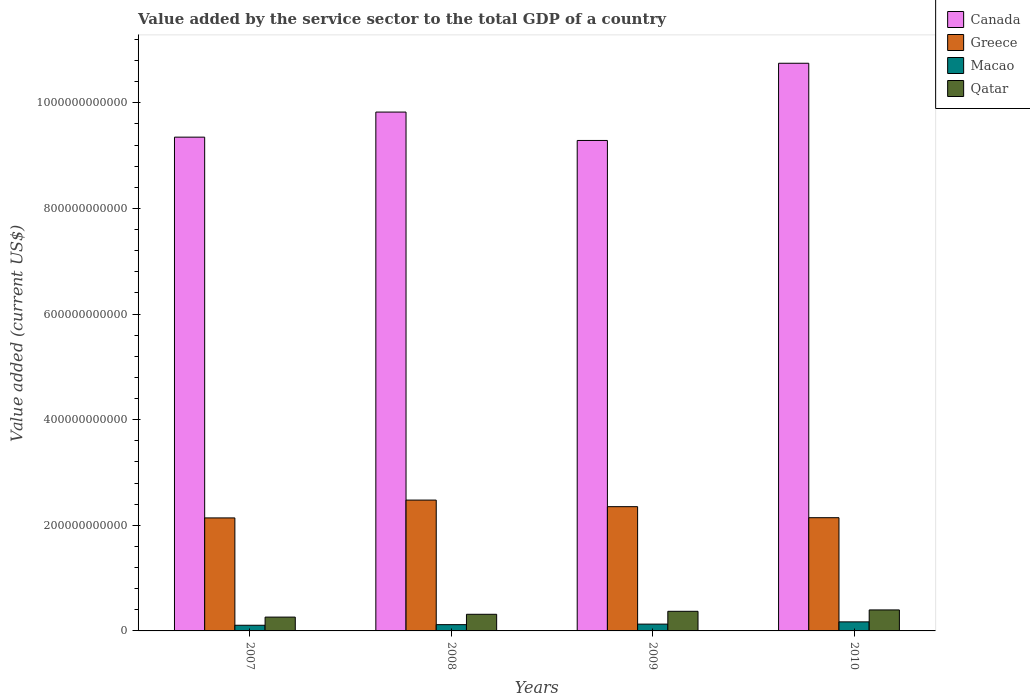How many groups of bars are there?
Ensure brevity in your answer.  4. Are the number of bars on each tick of the X-axis equal?
Offer a terse response. Yes. How many bars are there on the 3rd tick from the left?
Offer a very short reply. 4. What is the value added by the service sector to the total GDP in Canada in 2007?
Offer a very short reply. 9.35e+11. Across all years, what is the maximum value added by the service sector to the total GDP in Qatar?
Make the answer very short. 3.98e+1. Across all years, what is the minimum value added by the service sector to the total GDP in Qatar?
Give a very brief answer. 2.62e+1. In which year was the value added by the service sector to the total GDP in Macao minimum?
Make the answer very short. 2007. What is the total value added by the service sector to the total GDP in Macao in the graph?
Your response must be concise. 5.26e+1. What is the difference between the value added by the service sector to the total GDP in Macao in 2009 and that in 2010?
Give a very brief answer. -4.26e+09. What is the difference between the value added by the service sector to the total GDP in Qatar in 2010 and the value added by the service sector to the total GDP in Greece in 2009?
Offer a very short reply. -1.96e+11. What is the average value added by the service sector to the total GDP in Macao per year?
Provide a succinct answer. 1.32e+1. In the year 2007, what is the difference between the value added by the service sector to the total GDP in Qatar and value added by the service sector to the total GDP in Greece?
Your answer should be compact. -1.88e+11. What is the ratio of the value added by the service sector to the total GDP in Greece in 2008 to that in 2009?
Offer a very short reply. 1.05. Is the value added by the service sector to the total GDP in Qatar in 2007 less than that in 2009?
Your response must be concise. Yes. What is the difference between the highest and the second highest value added by the service sector to the total GDP in Macao?
Your response must be concise. 4.26e+09. What is the difference between the highest and the lowest value added by the service sector to the total GDP in Canada?
Your answer should be compact. 1.46e+11. In how many years, is the value added by the service sector to the total GDP in Qatar greater than the average value added by the service sector to the total GDP in Qatar taken over all years?
Provide a short and direct response. 2. Is the sum of the value added by the service sector to the total GDP in Qatar in 2007 and 2009 greater than the maximum value added by the service sector to the total GDP in Macao across all years?
Make the answer very short. Yes. What does the 4th bar from the left in 2009 represents?
Your response must be concise. Qatar. What does the 3rd bar from the right in 2007 represents?
Your response must be concise. Greece. How many bars are there?
Keep it short and to the point. 16. How many years are there in the graph?
Ensure brevity in your answer.  4. What is the difference between two consecutive major ticks on the Y-axis?
Offer a very short reply. 2.00e+11. Are the values on the major ticks of Y-axis written in scientific E-notation?
Give a very brief answer. No. How many legend labels are there?
Provide a short and direct response. 4. How are the legend labels stacked?
Give a very brief answer. Vertical. What is the title of the graph?
Keep it short and to the point. Value added by the service sector to the total GDP of a country. What is the label or title of the Y-axis?
Provide a short and direct response. Value added (current US$). What is the Value added (current US$) of Canada in 2007?
Offer a very short reply. 9.35e+11. What is the Value added (current US$) in Greece in 2007?
Make the answer very short. 2.14e+11. What is the Value added (current US$) in Macao in 2007?
Provide a short and direct response. 1.07e+1. What is the Value added (current US$) of Qatar in 2007?
Offer a very short reply. 2.62e+1. What is the Value added (current US$) in Canada in 2008?
Offer a very short reply. 9.82e+11. What is the Value added (current US$) in Greece in 2008?
Offer a terse response. 2.48e+11. What is the Value added (current US$) in Macao in 2008?
Your answer should be compact. 1.19e+1. What is the Value added (current US$) in Qatar in 2008?
Your answer should be compact. 3.15e+1. What is the Value added (current US$) of Canada in 2009?
Keep it short and to the point. 9.29e+11. What is the Value added (current US$) in Greece in 2009?
Provide a succinct answer. 2.35e+11. What is the Value added (current US$) in Macao in 2009?
Provide a succinct answer. 1.29e+1. What is the Value added (current US$) in Qatar in 2009?
Provide a succinct answer. 3.71e+1. What is the Value added (current US$) of Canada in 2010?
Your response must be concise. 1.07e+12. What is the Value added (current US$) in Greece in 2010?
Make the answer very short. 2.14e+11. What is the Value added (current US$) in Macao in 2010?
Ensure brevity in your answer.  1.71e+1. What is the Value added (current US$) of Qatar in 2010?
Provide a succinct answer. 3.98e+1. Across all years, what is the maximum Value added (current US$) in Canada?
Your response must be concise. 1.07e+12. Across all years, what is the maximum Value added (current US$) of Greece?
Your response must be concise. 2.48e+11. Across all years, what is the maximum Value added (current US$) of Macao?
Make the answer very short. 1.71e+1. Across all years, what is the maximum Value added (current US$) in Qatar?
Provide a short and direct response. 3.98e+1. Across all years, what is the minimum Value added (current US$) of Canada?
Provide a succinct answer. 9.29e+11. Across all years, what is the minimum Value added (current US$) in Greece?
Provide a succinct answer. 2.14e+11. Across all years, what is the minimum Value added (current US$) of Macao?
Your answer should be very brief. 1.07e+1. Across all years, what is the minimum Value added (current US$) of Qatar?
Offer a terse response. 2.62e+1. What is the total Value added (current US$) of Canada in the graph?
Ensure brevity in your answer.  3.92e+12. What is the total Value added (current US$) in Greece in the graph?
Provide a succinct answer. 9.11e+11. What is the total Value added (current US$) in Macao in the graph?
Your response must be concise. 5.26e+1. What is the total Value added (current US$) of Qatar in the graph?
Give a very brief answer. 1.35e+11. What is the difference between the Value added (current US$) of Canada in 2007 and that in 2008?
Provide a succinct answer. -4.75e+1. What is the difference between the Value added (current US$) of Greece in 2007 and that in 2008?
Provide a short and direct response. -3.38e+1. What is the difference between the Value added (current US$) in Macao in 2007 and that in 2008?
Keep it short and to the point. -1.15e+09. What is the difference between the Value added (current US$) of Qatar in 2007 and that in 2008?
Give a very brief answer. -5.32e+09. What is the difference between the Value added (current US$) in Canada in 2007 and that in 2009?
Your answer should be compact. 6.28e+09. What is the difference between the Value added (current US$) in Greece in 2007 and that in 2009?
Your answer should be compact. -2.13e+1. What is the difference between the Value added (current US$) of Macao in 2007 and that in 2009?
Ensure brevity in your answer.  -2.16e+09. What is the difference between the Value added (current US$) in Qatar in 2007 and that in 2009?
Your response must be concise. -1.10e+1. What is the difference between the Value added (current US$) of Canada in 2007 and that in 2010?
Your response must be concise. -1.40e+11. What is the difference between the Value added (current US$) of Greece in 2007 and that in 2010?
Keep it short and to the point. -4.38e+08. What is the difference between the Value added (current US$) in Macao in 2007 and that in 2010?
Your response must be concise. -6.41e+09. What is the difference between the Value added (current US$) in Qatar in 2007 and that in 2010?
Provide a succinct answer. -1.36e+1. What is the difference between the Value added (current US$) of Canada in 2008 and that in 2009?
Your response must be concise. 5.38e+1. What is the difference between the Value added (current US$) in Greece in 2008 and that in 2009?
Provide a succinct answer. 1.25e+1. What is the difference between the Value added (current US$) of Macao in 2008 and that in 2009?
Provide a short and direct response. -1.01e+09. What is the difference between the Value added (current US$) in Qatar in 2008 and that in 2009?
Keep it short and to the point. -5.65e+09. What is the difference between the Value added (current US$) of Canada in 2008 and that in 2010?
Your answer should be compact. -9.24e+1. What is the difference between the Value added (current US$) in Greece in 2008 and that in 2010?
Your answer should be very brief. 3.33e+1. What is the difference between the Value added (current US$) of Macao in 2008 and that in 2010?
Your response must be concise. -5.26e+09. What is the difference between the Value added (current US$) in Qatar in 2008 and that in 2010?
Keep it short and to the point. -8.27e+09. What is the difference between the Value added (current US$) in Canada in 2009 and that in 2010?
Make the answer very short. -1.46e+11. What is the difference between the Value added (current US$) of Greece in 2009 and that in 2010?
Your answer should be compact. 2.09e+1. What is the difference between the Value added (current US$) in Macao in 2009 and that in 2010?
Ensure brevity in your answer.  -4.26e+09. What is the difference between the Value added (current US$) of Qatar in 2009 and that in 2010?
Your answer should be compact. -2.62e+09. What is the difference between the Value added (current US$) of Canada in 2007 and the Value added (current US$) of Greece in 2008?
Ensure brevity in your answer.  6.87e+11. What is the difference between the Value added (current US$) in Canada in 2007 and the Value added (current US$) in Macao in 2008?
Offer a terse response. 9.23e+11. What is the difference between the Value added (current US$) of Canada in 2007 and the Value added (current US$) of Qatar in 2008?
Provide a succinct answer. 9.03e+11. What is the difference between the Value added (current US$) of Greece in 2007 and the Value added (current US$) of Macao in 2008?
Offer a terse response. 2.02e+11. What is the difference between the Value added (current US$) in Greece in 2007 and the Value added (current US$) in Qatar in 2008?
Your answer should be compact. 1.82e+11. What is the difference between the Value added (current US$) of Macao in 2007 and the Value added (current US$) of Qatar in 2008?
Give a very brief answer. -2.08e+1. What is the difference between the Value added (current US$) in Canada in 2007 and the Value added (current US$) in Greece in 2009?
Offer a very short reply. 7.00e+11. What is the difference between the Value added (current US$) in Canada in 2007 and the Value added (current US$) in Macao in 2009?
Offer a very short reply. 9.22e+11. What is the difference between the Value added (current US$) of Canada in 2007 and the Value added (current US$) of Qatar in 2009?
Offer a terse response. 8.98e+11. What is the difference between the Value added (current US$) of Greece in 2007 and the Value added (current US$) of Macao in 2009?
Provide a short and direct response. 2.01e+11. What is the difference between the Value added (current US$) in Greece in 2007 and the Value added (current US$) in Qatar in 2009?
Offer a very short reply. 1.77e+11. What is the difference between the Value added (current US$) of Macao in 2007 and the Value added (current US$) of Qatar in 2009?
Make the answer very short. -2.64e+1. What is the difference between the Value added (current US$) in Canada in 2007 and the Value added (current US$) in Greece in 2010?
Give a very brief answer. 7.21e+11. What is the difference between the Value added (current US$) in Canada in 2007 and the Value added (current US$) in Macao in 2010?
Provide a short and direct response. 9.18e+11. What is the difference between the Value added (current US$) in Canada in 2007 and the Value added (current US$) in Qatar in 2010?
Offer a terse response. 8.95e+11. What is the difference between the Value added (current US$) of Greece in 2007 and the Value added (current US$) of Macao in 2010?
Ensure brevity in your answer.  1.97e+11. What is the difference between the Value added (current US$) in Greece in 2007 and the Value added (current US$) in Qatar in 2010?
Make the answer very short. 1.74e+11. What is the difference between the Value added (current US$) in Macao in 2007 and the Value added (current US$) in Qatar in 2010?
Offer a very short reply. -2.90e+1. What is the difference between the Value added (current US$) in Canada in 2008 and the Value added (current US$) in Greece in 2009?
Provide a short and direct response. 7.47e+11. What is the difference between the Value added (current US$) in Canada in 2008 and the Value added (current US$) in Macao in 2009?
Your answer should be very brief. 9.70e+11. What is the difference between the Value added (current US$) of Canada in 2008 and the Value added (current US$) of Qatar in 2009?
Your answer should be compact. 9.45e+11. What is the difference between the Value added (current US$) of Greece in 2008 and the Value added (current US$) of Macao in 2009?
Provide a succinct answer. 2.35e+11. What is the difference between the Value added (current US$) of Greece in 2008 and the Value added (current US$) of Qatar in 2009?
Provide a succinct answer. 2.11e+11. What is the difference between the Value added (current US$) of Macao in 2008 and the Value added (current US$) of Qatar in 2009?
Give a very brief answer. -2.53e+1. What is the difference between the Value added (current US$) of Canada in 2008 and the Value added (current US$) of Greece in 2010?
Your response must be concise. 7.68e+11. What is the difference between the Value added (current US$) of Canada in 2008 and the Value added (current US$) of Macao in 2010?
Your response must be concise. 9.65e+11. What is the difference between the Value added (current US$) of Canada in 2008 and the Value added (current US$) of Qatar in 2010?
Keep it short and to the point. 9.43e+11. What is the difference between the Value added (current US$) in Greece in 2008 and the Value added (current US$) in Macao in 2010?
Your response must be concise. 2.31e+11. What is the difference between the Value added (current US$) of Greece in 2008 and the Value added (current US$) of Qatar in 2010?
Offer a very short reply. 2.08e+11. What is the difference between the Value added (current US$) of Macao in 2008 and the Value added (current US$) of Qatar in 2010?
Your answer should be compact. -2.79e+1. What is the difference between the Value added (current US$) in Canada in 2009 and the Value added (current US$) in Greece in 2010?
Keep it short and to the point. 7.14e+11. What is the difference between the Value added (current US$) in Canada in 2009 and the Value added (current US$) in Macao in 2010?
Provide a short and direct response. 9.12e+11. What is the difference between the Value added (current US$) of Canada in 2009 and the Value added (current US$) of Qatar in 2010?
Your response must be concise. 8.89e+11. What is the difference between the Value added (current US$) of Greece in 2009 and the Value added (current US$) of Macao in 2010?
Your answer should be very brief. 2.18e+11. What is the difference between the Value added (current US$) in Greece in 2009 and the Value added (current US$) in Qatar in 2010?
Keep it short and to the point. 1.96e+11. What is the difference between the Value added (current US$) of Macao in 2009 and the Value added (current US$) of Qatar in 2010?
Offer a terse response. -2.69e+1. What is the average Value added (current US$) of Canada per year?
Provide a succinct answer. 9.80e+11. What is the average Value added (current US$) in Greece per year?
Ensure brevity in your answer.  2.28e+11. What is the average Value added (current US$) in Macao per year?
Keep it short and to the point. 1.32e+1. What is the average Value added (current US$) of Qatar per year?
Make the answer very short. 3.36e+1. In the year 2007, what is the difference between the Value added (current US$) in Canada and Value added (current US$) in Greece?
Make the answer very short. 7.21e+11. In the year 2007, what is the difference between the Value added (current US$) in Canada and Value added (current US$) in Macao?
Your response must be concise. 9.24e+11. In the year 2007, what is the difference between the Value added (current US$) of Canada and Value added (current US$) of Qatar?
Offer a terse response. 9.09e+11. In the year 2007, what is the difference between the Value added (current US$) in Greece and Value added (current US$) in Macao?
Ensure brevity in your answer.  2.03e+11. In the year 2007, what is the difference between the Value added (current US$) of Greece and Value added (current US$) of Qatar?
Keep it short and to the point. 1.88e+11. In the year 2007, what is the difference between the Value added (current US$) in Macao and Value added (current US$) in Qatar?
Provide a succinct answer. -1.55e+1. In the year 2008, what is the difference between the Value added (current US$) in Canada and Value added (current US$) in Greece?
Your answer should be very brief. 7.35e+11. In the year 2008, what is the difference between the Value added (current US$) of Canada and Value added (current US$) of Macao?
Make the answer very short. 9.71e+11. In the year 2008, what is the difference between the Value added (current US$) of Canada and Value added (current US$) of Qatar?
Offer a very short reply. 9.51e+11. In the year 2008, what is the difference between the Value added (current US$) of Greece and Value added (current US$) of Macao?
Offer a terse response. 2.36e+11. In the year 2008, what is the difference between the Value added (current US$) of Greece and Value added (current US$) of Qatar?
Ensure brevity in your answer.  2.16e+11. In the year 2008, what is the difference between the Value added (current US$) of Macao and Value added (current US$) of Qatar?
Make the answer very short. -1.96e+1. In the year 2009, what is the difference between the Value added (current US$) in Canada and Value added (current US$) in Greece?
Give a very brief answer. 6.93e+11. In the year 2009, what is the difference between the Value added (current US$) in Canada and Value added (current US$) in Macao?
Offer a very short reply. 9.16e+11. In the year 2009, what is the difference between the Value added (current US$) in Canada and Value added (current US$) in Qatar?
Your answer should be very brief. 8.92e+11. In the year 2009, what is the difference between the Value added (current US$) of Greece and Value added (current US$) of Macao?
Offer a very short reply. 2.22e+11. In the year 2009, what is the difference between the Value added (current US$) in Greece and Value added (current US$) in Qatar?
Provide a short and direct response. 1.98e+11. In the year 2009, what is the difference between the Value added (current US$) in Macao and Value added (current US$) in Qatar?
Make the answer very short. -2.43e+1. In the year 2010, what is the difference between the Value added (current US$) of Canada and Value added (current US$) of Greece?
Provide a succinct answer. 8.60e+11. In the year 2010, what is the difference between the Value added (current US$) of Canada and Value added (current US$) of Macao?
Provide a succinct answer. 1.06e+12. In the year 2010, what is the difference between the Value added (current US$) in Canada and Value added (current US$) in Qatar?
Give a very brief answer. 1.04e+12. In the year 2010, what is the difference between the Value added (current US$) of Greece and Value added (current US$) of Macao?
Make the answer very short. 1.97e+11. In the year 2010, what is the difference between the Value added (current US$) in Greece and Value added (current US$) in Qatar?
Offer a very short reply. 1.75e+11. In the year 2010, what is the difference between the Value added (current US$) in Macao and Value added (current US$) in Qatar?
Give a very brief answer. -2.26e+1. What is the ratio of the Value added (current US$) of Canada in 2007 to that in 2008?
Give a very brief answer. 0.95. What is the ratio of the Value added (current US$) in Greece in 2007 to that in 2008?
Give a very brief answer. 0.86. What is the ratio of the Value added (current US$) of Macao in 2007 to that in 2008?
Ensure brevity in your answer.  0.9. What is the ratio of the Value added (current US$) in Qatar in 2007 to that in 2008?
Keep it short and to the point. 0.83. What is the ratio of the Value added (current US$) in Canada in 2007 to that in 2009?
Offer a very short reply. 1.01. What is the ratio of the Value added (current US$) of Greece in 2007 to that in 2009?
Provide a short and direct response. 0.91. What is the ratio of the Value added (current US$) in Macao in 2007 to that in 2009?
Provide a short and direct response. 0.83. What is the ratio of the Value added (current US$) of Qatar in 2007 to that in 2009?
Make the answer very short. 0.7. What is the ratio of the Value added (current US$) in Canada in 2007 to that in 2010?
Offer a terse response. 0.87. What is the ratio of the Value added (current US$) in Macao in 2007 to that in 2010?
Provide a short and direct response. 0.63. What is the ratio of the Value added (current US$) of Qatar in 2007 to that in 2010?
Your response must be concise. 0.66. What is the ratio of the Value added (current US$) of Canada in 2008 to that in 2009?
Ensure brevity in your answer.  1.06. What is the ratio of the Value added (current US$) of Greece in 2008 to that in 2009?
Provide a short and direct response. 1.05. What is the ratio of the Value added (current US$) of Macao in 2008 to that in 2009?
Give a very brief answer. 0.92. What is the ratio of the Value added (current US$) in Qatar in 2008 to that in 2009?
Your answer should be very brief. 0.85. What is the ratio of the Value added (current US$) in Canada in 2008 to that in 2010?
Offer a terse response. 0.91. What is the ratio of the Value added (current US$) in Greece in 2008 to that in 2010?
Provide a succinct answer. 1.16. What is the ratio of the Value added (current US$) of Macao in 2008 to that in 2010?
Your response must be concise. 0.69. What is the ratio of the Value added (current US$) of Qatar in 2008 to that in 2010?
Make the answer very short. 0.79. What is the ratio of the Value added (current US$) of Canada in 2009 to that in 2010?
Your response must be concise. 0.86. What is the ratio of the Value added (current US$) of Greece in 2009 to that in 2010?
Keep it short and to the point. 1.1. What is the ratio of the Value added (current US$) of Macao in 2009 to that in 2010?
Keep it short and to the point. 0.75. What is the ratio of the Value added (current US$) of Qatar in 2009 to that in 2010?
Keep it short and to the point. 0.93. What is the difference between the highest and the second highest Value added (current US$) of Canada?
Your response must be concise. 9.24e+1. What is the difference between the highest and the second highest Value added (current US$) of Greece?
Your answer should be compact. 1.25e+1. What is the difference between the highest and the second highest Value added (current US$) of Macao?
Ensure brevity in your answer.  4.26e+09. What is the difference between the highest and the second highest Value added (current US$) of Qatar?
Offer a terse response. 2.62e+09. What is the difference between the highest and the lowest Value added (current US$) in Canada?
Ensure brevity in your answer.  1.46e+11. What is the difference between the highest and the lowest Value added (current US$) of Greece?
Your answer should be very brief. 3.38e+1. What is the difference between the highest and the lowest Value added (current US$) of Macao?
Your answer should be very brief. 6.41e+09. What is the difference between the highest and the lowest Value added (current US$) in Qatar?
Give a very brief answer. 1.36e+1. 